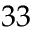Convert formula to latex. <formula><loc_0><loc_0><loc_500><loc_500>3 3</formula> 